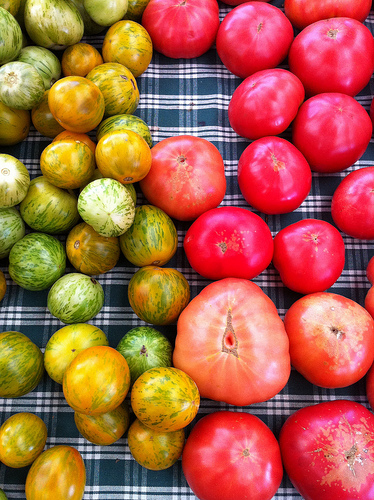<image>
Can you confirm if the tomato is next to the lime? No. The tomato is not positioned next to the lime. They are located in different areas of the scene. 